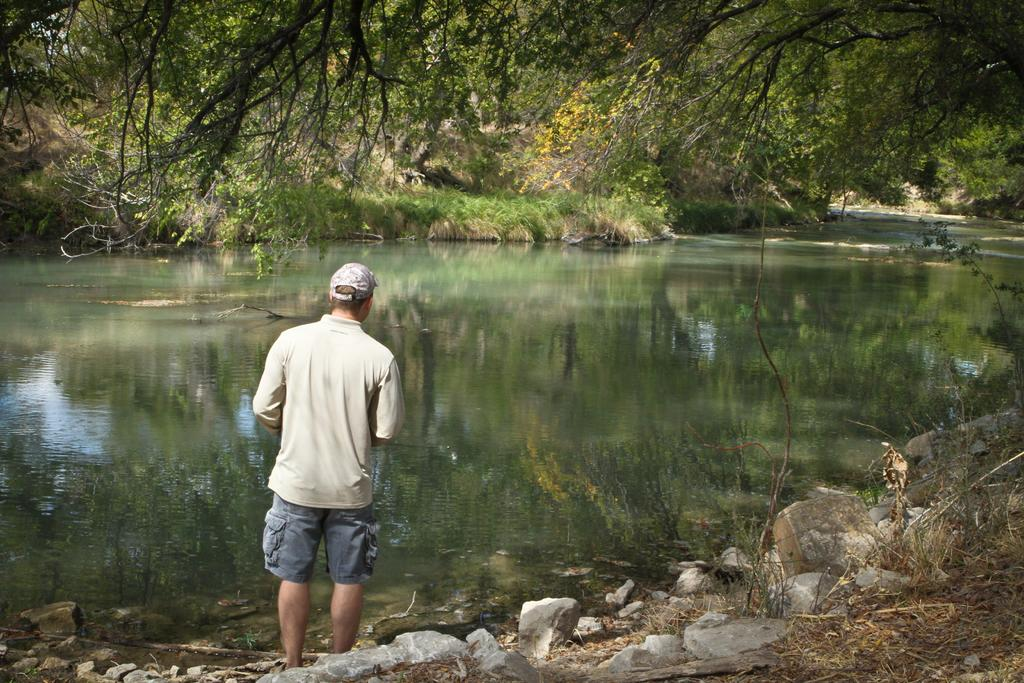What is the main subject of the image? There is a man standing in the image. What is the man wearing on his head? The man is wearing a cap. What type of terrain is visible at the bottom of the image? There are rocks and dry grass at the bottom of the image. What can be seen in the middle of the image? There is water in the middle of the image. What is visible in the background of the image? There are many trees in the background of the image. How does the man compare the taste of the pie in the image to the taste of the water? There is no pie present in the image, so it is not possible to compare its taste to the water. 